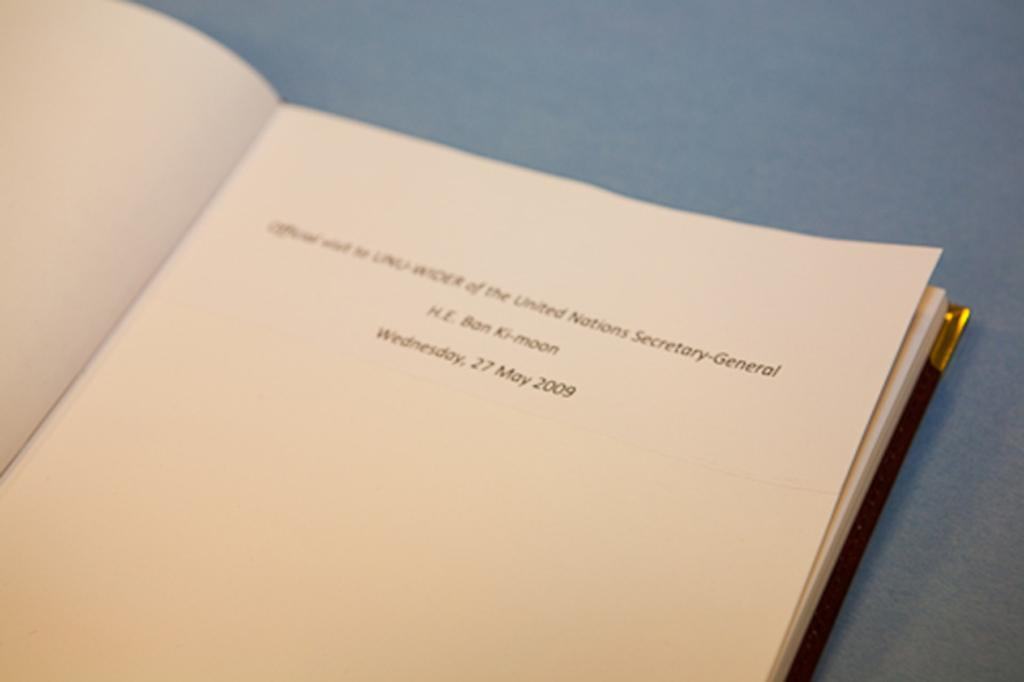Provide a one-sentence caption for the provided image. The first page of a journal belonging to Ban Ki-Moon indicating his position within the office of the United Nations Secretary-General. 